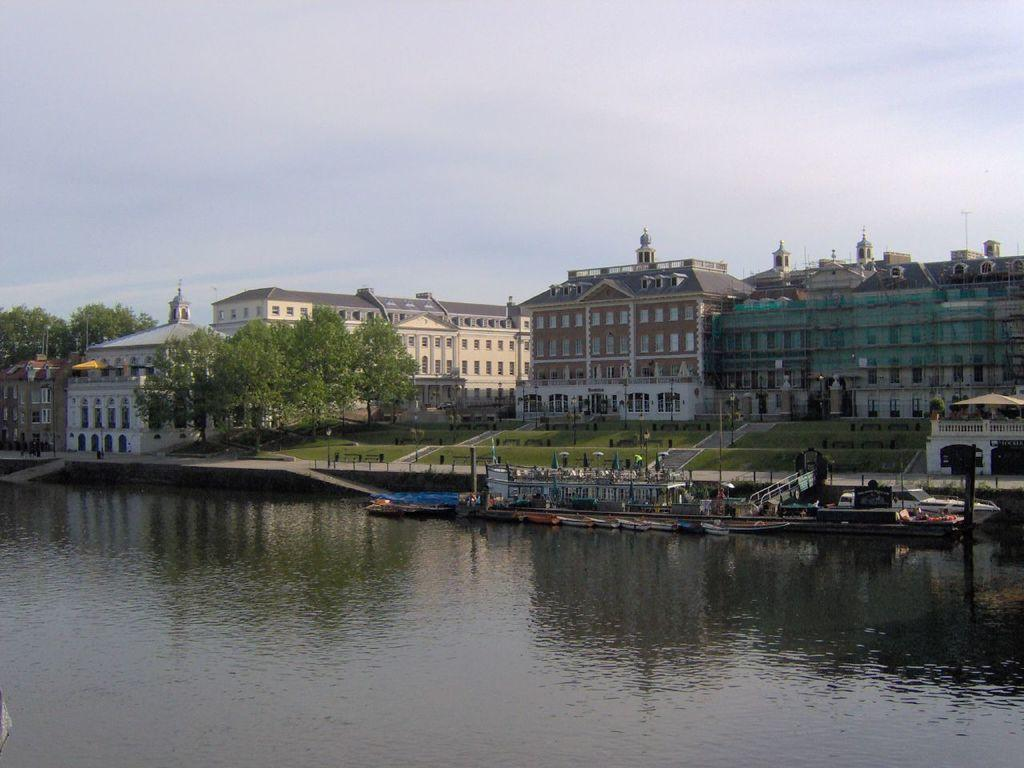What is on the water in the image? There are boats on the water in the image. What type of vegetation can be seen in the image? Trees are visible in the image. What type of structures are present in the image? Buildings with windows are present in the image. What type of ground surface is visible in the image? Grass is visible in the image. What type of objects are present in the image that might be used for support or signage? Poles are present in the image. What is visible in the background of the image? The sky with clouds is visible in the background of the image. How many visitors are sitting on the can in the image? There is no can or visitors present in the image. What type of dirt is visible on the boats in the image? There is no dirt visible on the boats in the image. 